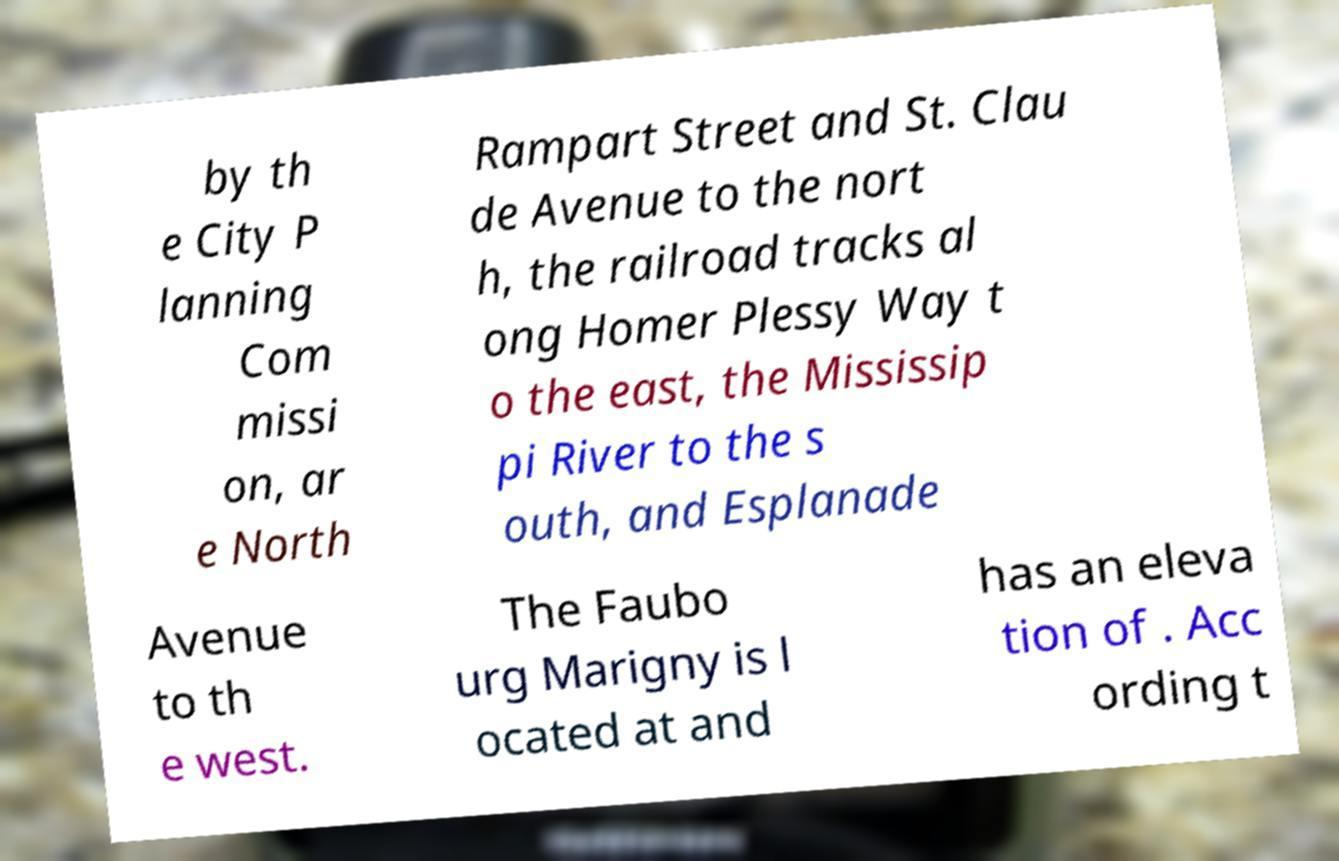I need the written content from this picture converted into text. Can you do that? by th e City P lanning Com missi on, ar e North Rampart Street and St. Clau de Avenue to the nort h, the railroad tracks al ong Homer Plessy Way t o the east, the Mississip pi River to the s outh, and Esplanade Avenue to th e west. The Faubo urg Marigny is l ocated at and has an eleva tion of . Acc ording t 